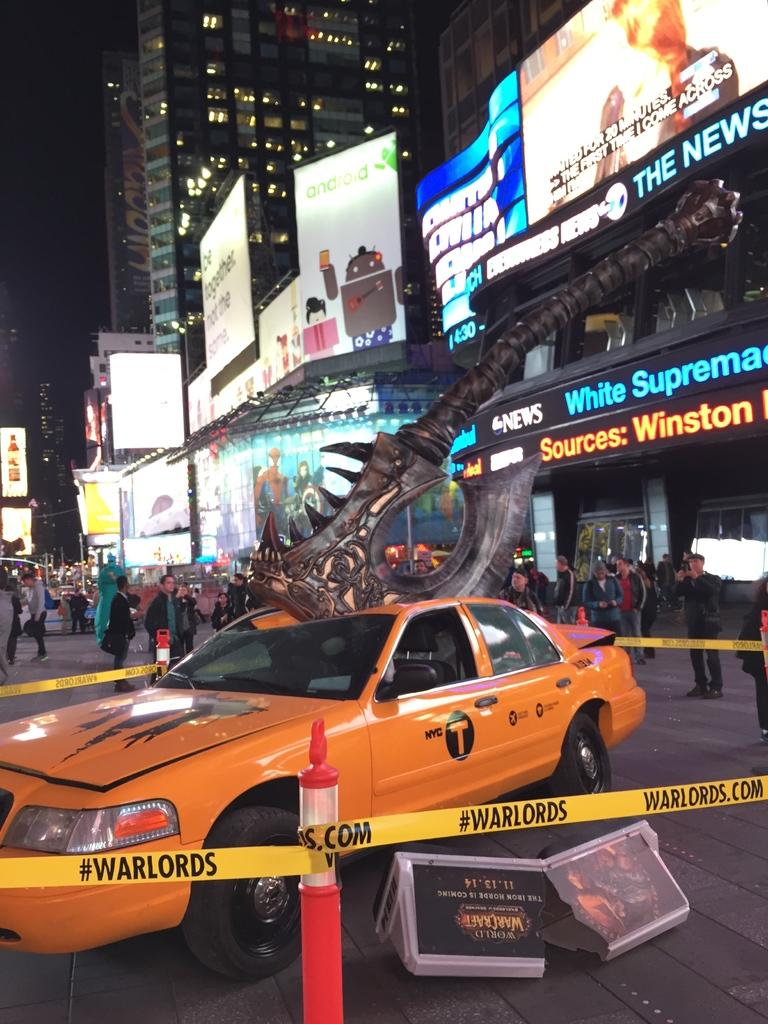Provide a one-sentence caption for the provided image. Yellow caution tape surrounding a cab reads warlords. 